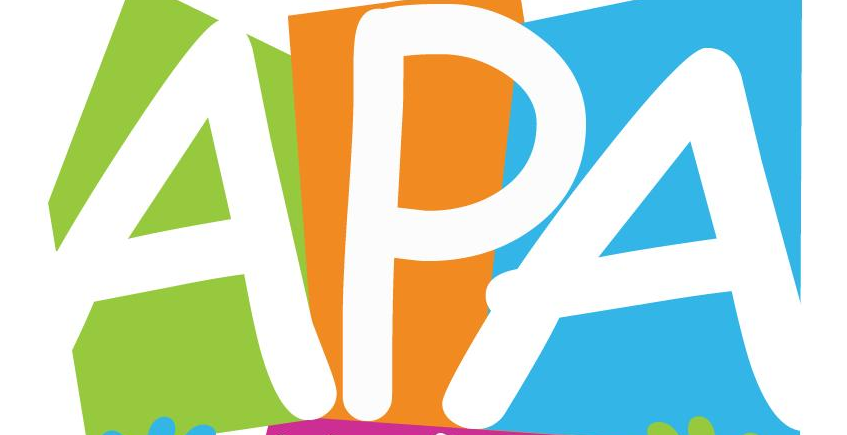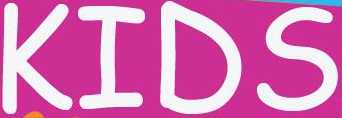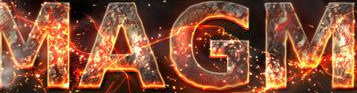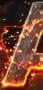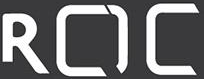Read the text from these images in sequence, separated by a semicolon. APA; KIDS; MAGM; #; ROC 